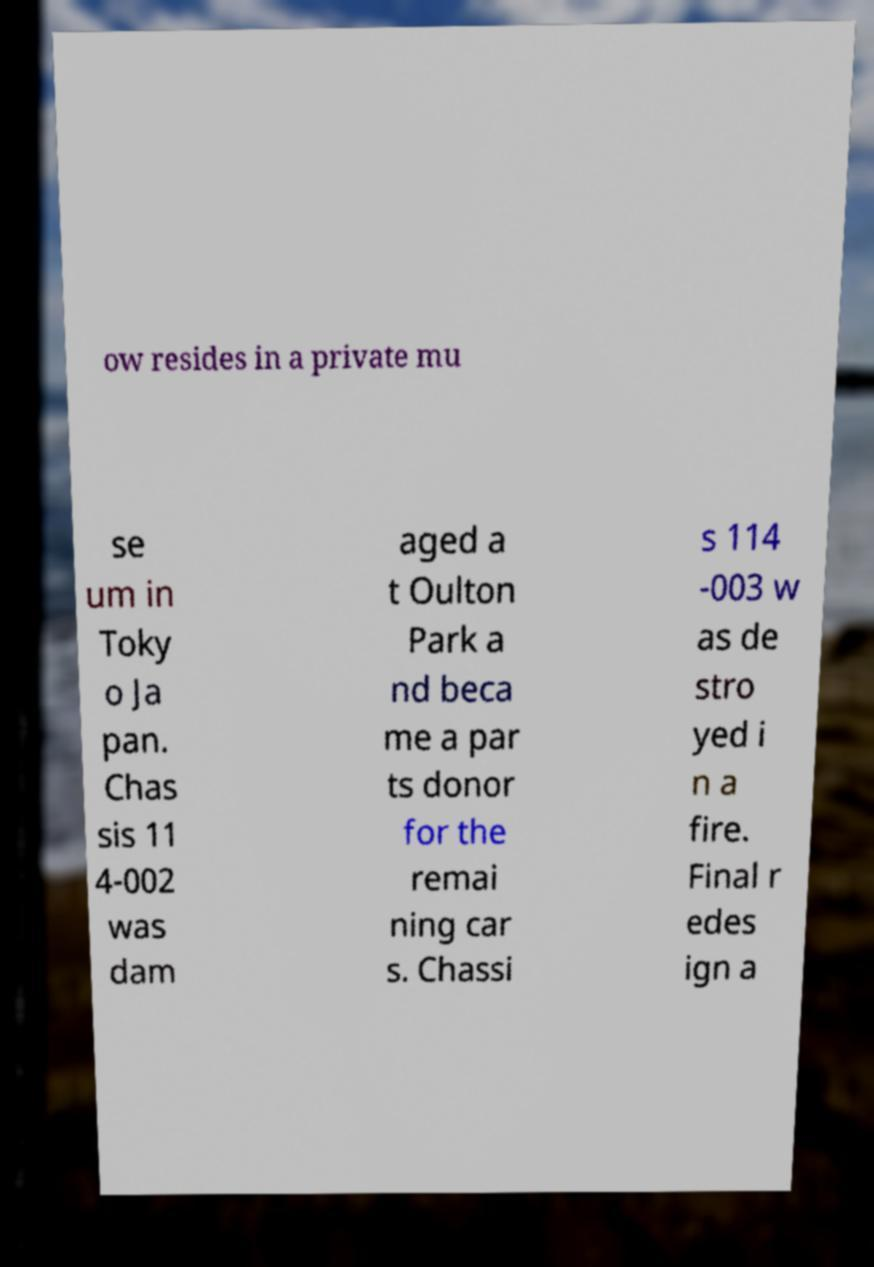For documentation purposes, I need the text within this image transcribed. Could you provide that? ow resides in a private mu se um in Toky o Ja pan. Chas sis 11 4-002 was dam aged a t Oulton Park a nd beca me a par ts donor for the remai ning car s. Chassi s 114 -003 w as de stro yed i n a fire. Final r edes ign a 